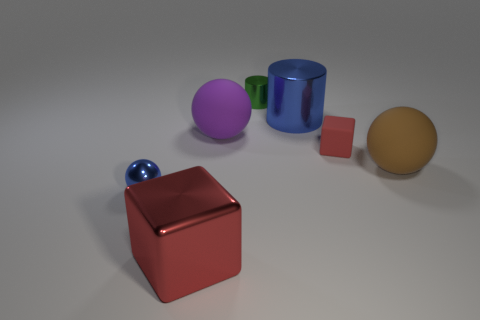There is a small thing that is the same color as the large metallic block; what is it made of?
Your answer should be very brief. Rubber. How many red things have the same size as the green metal cylinder?
Your answer should be compact. 1. Do the brown ball that is on the right side of the tiny blue ball and the small red thing have the same material?
Your answer should be compact. Yes. Are there any big metal cylinders that are on the right side of the tiny thing behind the matte cube?
Your response must be concise. Yes. There is a large blue object that is the same shape as the small green object; what material is it?
Ensure brevity in your answer.  Metal. Are there more shiny things that are in front of the large block than tiny balls behind the small green thing?
Your answer should be very brief. No. There is a tiny green object that is the same material as the tiny sphere; what shape is it?
Give a very brief answer. Cylinder. Are there more big rubber spheres behind the large brown rubber thing than small blue metal spheres?
Keep it short and to the point. No. What number of other small matte cubes are the same color as the small cube?
Provide a short and direct response. 0. What number of other objects are there of the same color as the matte cube?
Ensure brevity in your answer.  1. 